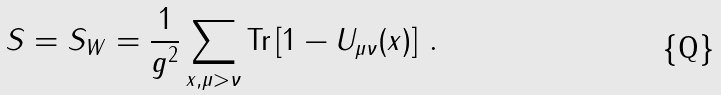Convert formula to latex. <formula><loc_0><loc_0><loc_500><loc_500>S = S _ { W } = \frac { 1 } { g ^ { 2 } } \sum _ { x , \mu > \nu } { \text {Tr} } \left [ 1 - U _ { \mu \nu } ( x ) \right ] \, .</formula> 